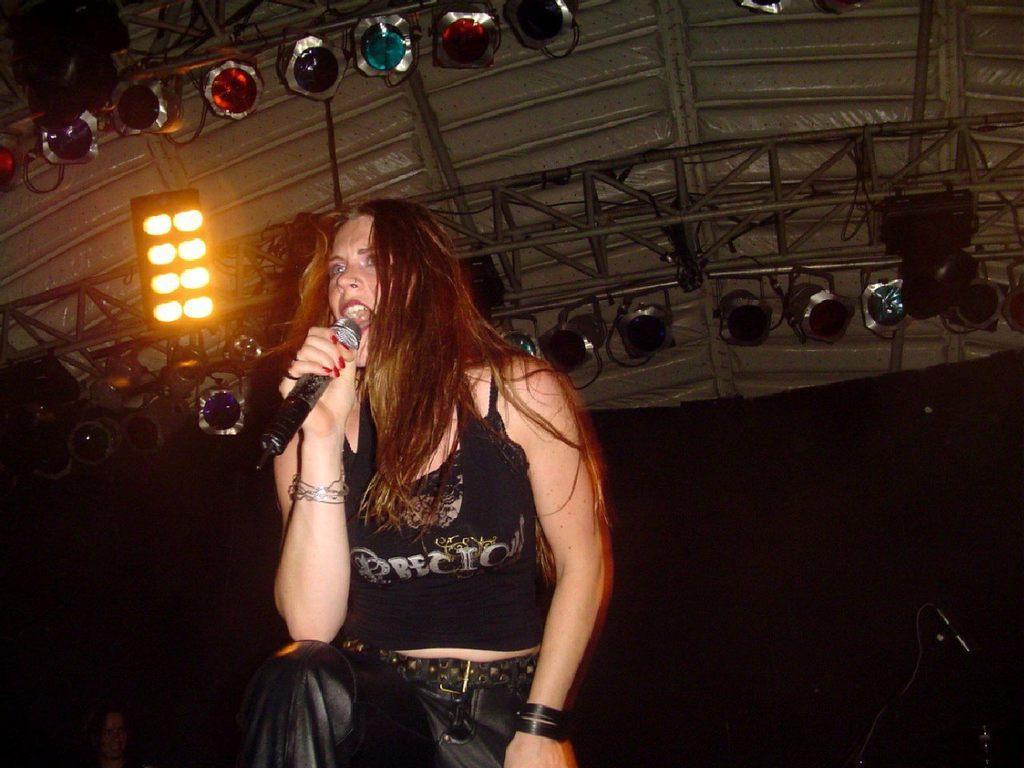Could you give a brief overview of what you see in this image? In this image I can see a person and the person is holding a microphone and singing. The person is wearing black color dress, background I can see few poles and few lights. 